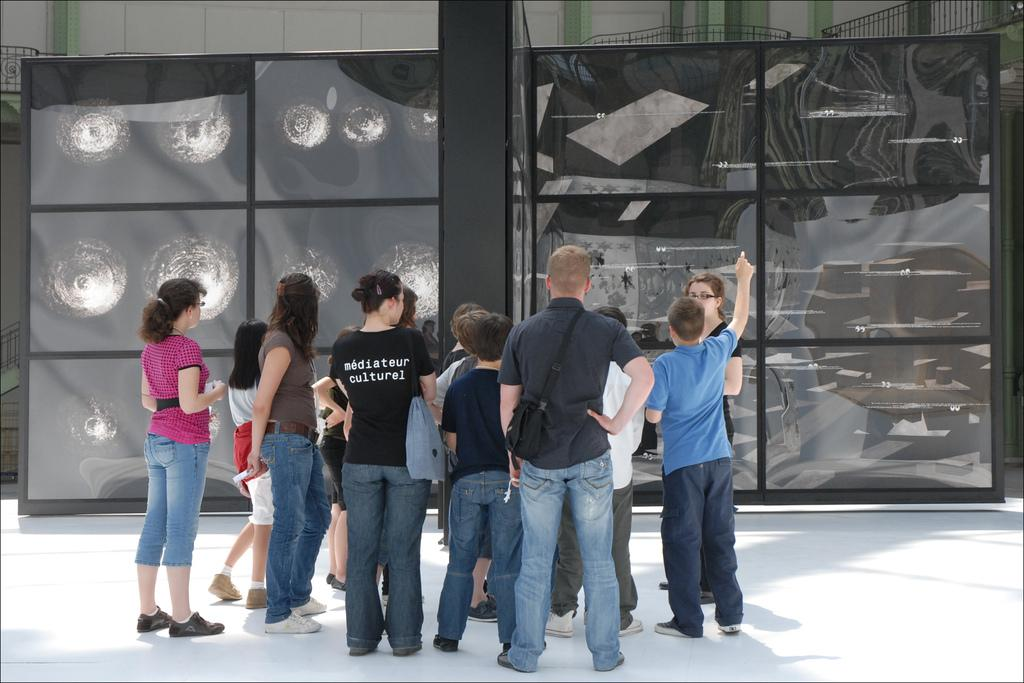What are the people in the image doing? The people in the image are standing. Where are the people standing in the image? The people are standing on the floor. What can be seen on the black colored objects in the image? The black colored objects have images on them. What can be used for support or safety in the image? Railings are present in the image. What is visible in the background of the image? There is a wall in the background of the image. Who is the manager in the image? There is no mention of a manager in the image. What type of cough can be heard from the people in the image? There is no indication of any coughing in the image, as it only shows people standing. 